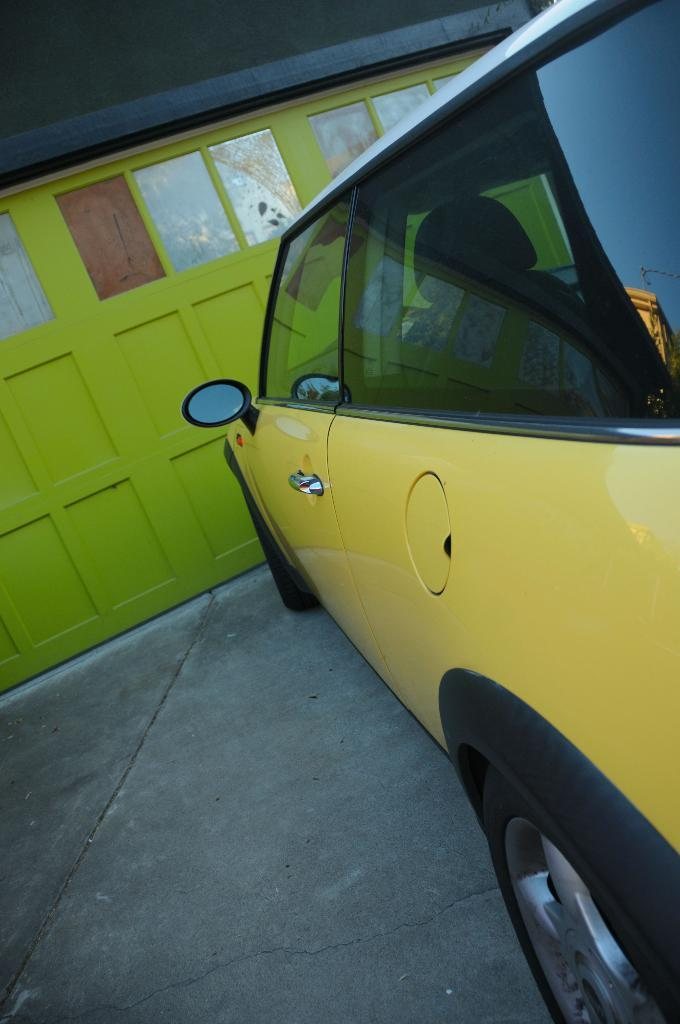What is the main subject of the picture? The main subject of the picture is a car. What color is the car? The car is yellow in color. What features can be seen on the car? The car has side mirrors and wheels. What is in front of the car in the picture? There is a wall in front of the car. What color is the wall? The wall is light green in color. How does the car gain knowledge about the world in the image? The car does not gain knowledge in the image, as it is an inanimate object and cannot think or learn. What type of spring can be seen on the car in the image? There is no spring present on the car in the image. 